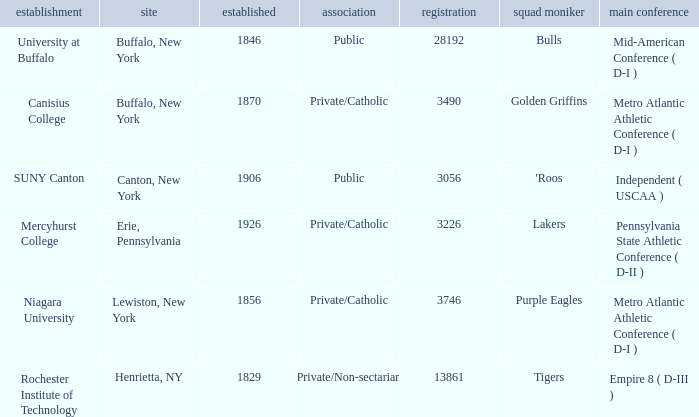What was the enrollment of the school founded in 1846? 28192.0. 